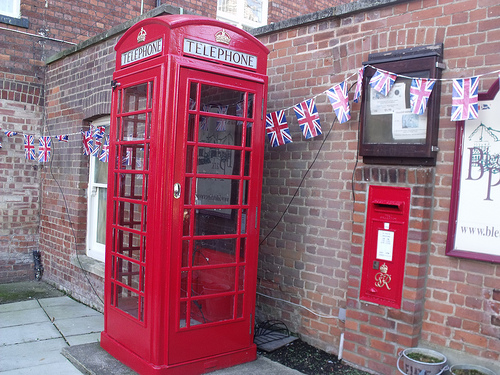<image>
Can you confirm if the booth is under the pavement? No. The booth is not positioned under the pavement. The vertical relationship between these objects is different. Is there a telephone booth in front of the flag? Yes. The telephone booth is positioned in front of the flag, appearing closer to the camera viewpoint. 